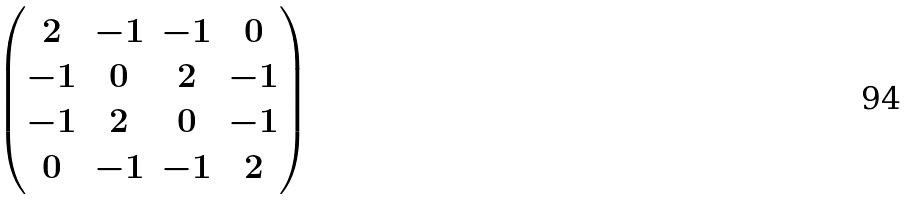<formula> <loc_0><loc_0><loc_500><loc_500>\begin{pmatrix} 2 & - 1 & - 1 & 0 \\ - 1 & 0 & 2 & - 1 \\ - 1 & 2 & 0 & - 1 \\ 0 & - 1 & - 1 & 2 \end{pmatrix}</formula> 